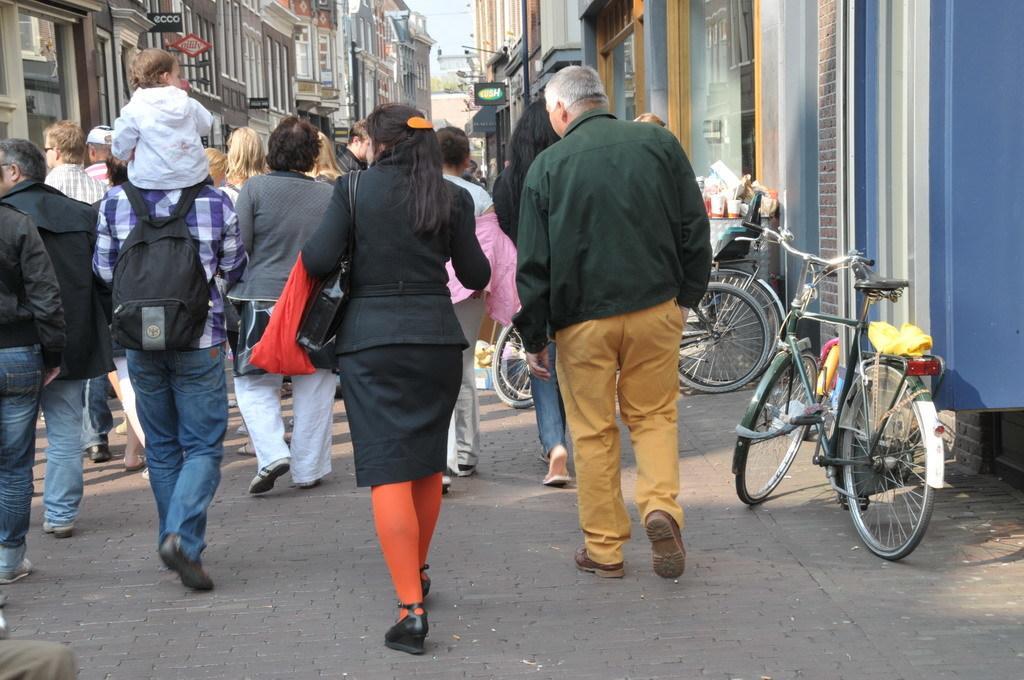Describe this image in one or two sentences. In this picture I can see some people are walking on the road, side we can see few vehicles and also I can see some buildings around. 